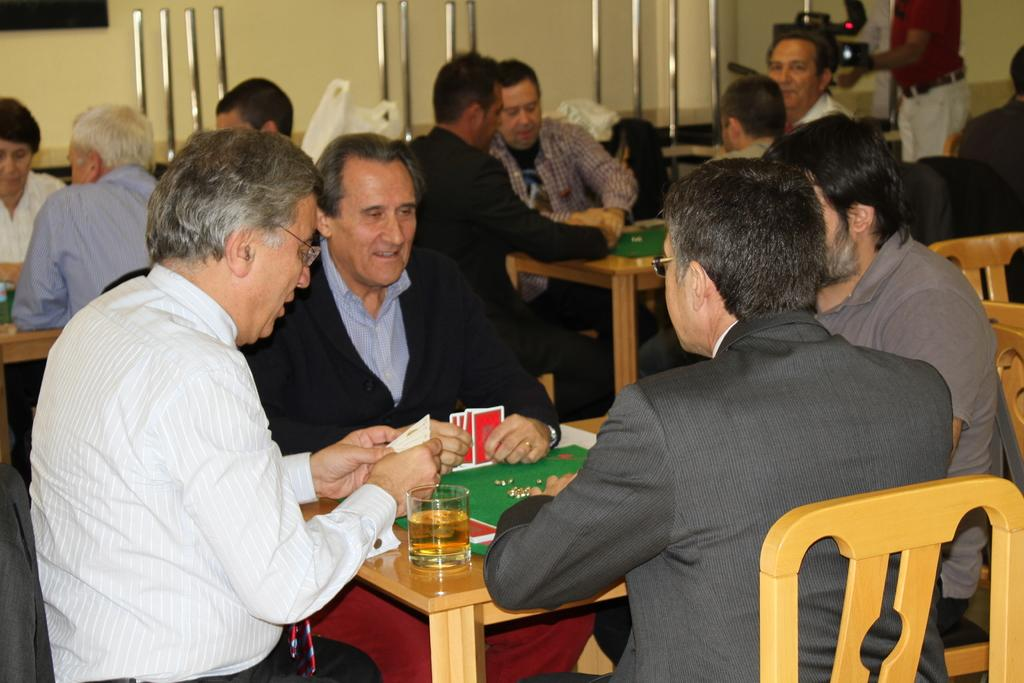What activity are the people in the image engaged in? The people in the image are playing cards. How many people are playing cards in the image? There are four people sitting around the table. What can be seen on the table besides the people? There is a glass, cards, and a mat on the table. Who is the creator of the worm that can be seen on the stage in the image? There is no worm or stage present in the image; it features people playing cards around a table. 